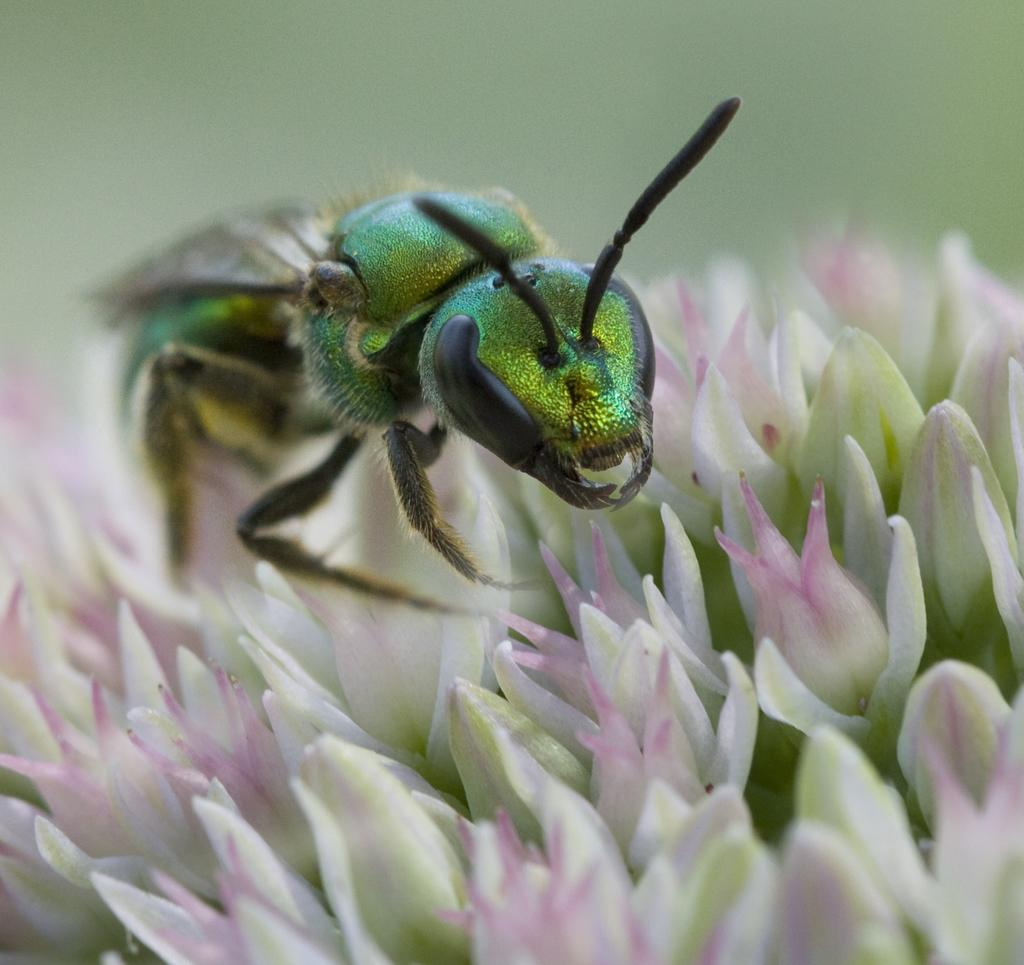What is the main subject of the image? The main subject of the image is an insect. What is the insect doing in the image? The insect is laying on flowers. How many cattle can be seen grazing in the background of the image? There are no cattle present in the image; it is a zoomed-in picture of an insect laying on flowers. What type of lighting is used to illuminate the insect in the image? The image does not provide information about the lighting used; it is a photograph of an insect laying on flowers. 